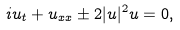Convert formula to latex. <formula><loc_0><loc_0><loc_500><loc_500>i u _ { t } + u _ { x x } \pm 2 | u | ^ { 2 } u = 0 ,</formula> 